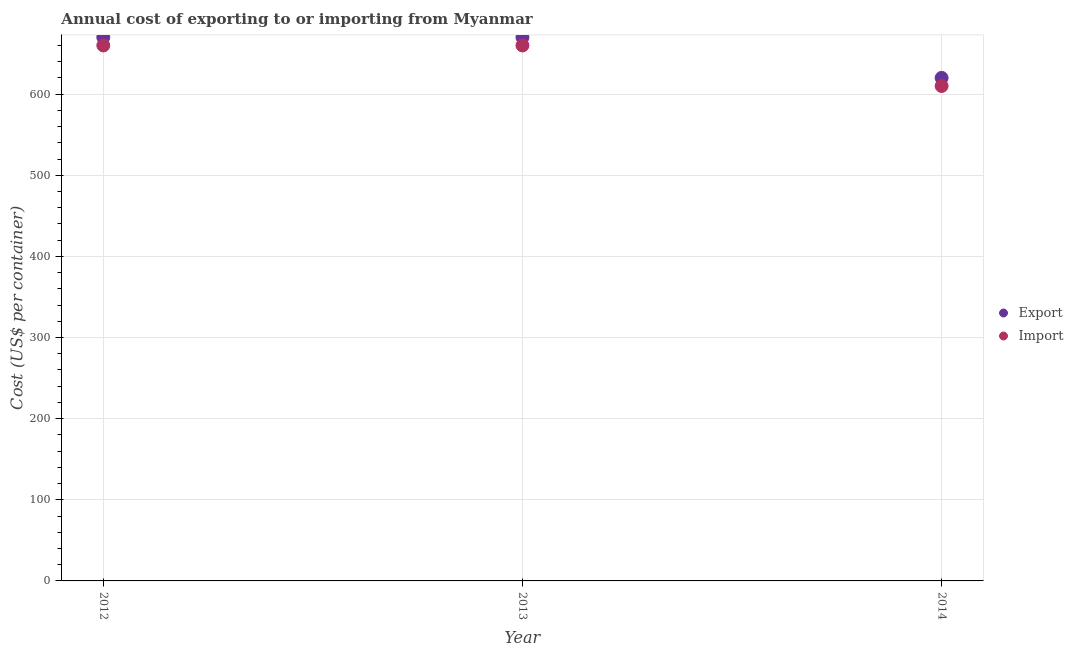Is the number of dotlines equal to the number of legend labels?
Your answer should be compact. Yes. What is the import cost in 2013?
Your response must be concise. 660. Across all years, what is the maximum import cost?
Offer a very short reply. 660. Across all years, what is the minimum export cost?
Ensure brevity in your answer.  620. In which year was the export cost maximum?
Your answer should be very brief. 2012. In which year was the export cost minimum?
Keep it short and to the point. 2014. What is the total import cost in the graph?
Provide a succinct answer. 1930. What is the difference between the import cost in 2014 and the export cost in 2012?
Offer a terse response. -60. What is the average import cost per year?
Your response must be concise. 643.33. In the year 2013, what is the difference between the import cost and export cost?
Ensure brevity in your answer.  -10. What is the ratio of the export cost in 2013 to that in 2014?
Your answer should be very brief. 1.08. Is the import cost in 2012 less than that in 2014?
Offer a terse response. No. Is the difference between the export cost in 2012 and 2013 greater than the difference between the import cost in 2012 and 2013?
Make the answer very short. No. What is the difference between the highest and the second highest export cost?
Ensure brevity in your answer.  0. What is the difference between the highest and the lowest import cost?
Offer a very short reply. 50. In how many years, is the import cost greater than the average import cost taken over all years?
Your answer should be compact. 2. Is the import cost strictly less than the export cost over the years?
Give a very brief answer. Yes. How many dotlines are there?
Make the answer very short. 2. How many years are there in the graph?
Make the answer very short. 3. Does the graph contain any zero values?
Provide a short and direct response. No. Does the graph contain grids?
Your answer should be compact. Yes. How many legend labels are there?
Provide a short and direct response. 2. What is the title of the graph?
Make the answer very short. Annual cost of exporting to or importing from Myanmar. Does "Lower secondary rate" appear as one of the legend labels in the graph?
Provide a short and direct response. No. What is the label or title of the Y-axis?
Keep it short and to the point. Cost (US$ per container). What is the Cost (US$ per container) in Export in 2012?
Ensure brevity in your answer.  670. What is the Cost (US$ per container) of Import in 2012?
Provide a succinct answer. 660. What is the Cost (US$ per container) in Export in 2013?
Ensure brevity in your answer.  670. What is the Cost (US$ per container) in Import in 2013?
Offer a very short reply. 660. What is the Cost (US$ per container) of Export in 2014?
Offer a very short reply. 620. What is the Cost (US$ per container) in Import in 2014?
Provide a succinct answer. 610. Across all years, what is the maximum Cost (US$ per container) of Export?
Offer a very short reply. 670. Across all years, what is the maximum Cost (US$ per container) in Import?
Make the answer very short. 660. Across all years, what is the minimum Cost (US$ per container) in Export?
Offer a terse response. 620. Across all years, what is the minimum Cost (US$ per container) of Import?
Your response must be concise. 610. What is the total Cost (US$ per container) of Export in the graph?
Ensure brevity in your answer.  1960. What is the total Cost (US$ per container) of Import in the graph?
Keep it short and to the point. 1930. What is the difference between the Cost (US$ per container) in Import in 2012 and that in 2013?
Your response must be concise. 0. What is the difference between the Cost (US$ per container) of Export in 2012 and that in 2014?
Offer a very short reply. 50. What is the difference between the Cost (US$ per container) of Import in 2013 and that in 2014?
Offer a very short reply. 50. What is the average Cost (US$ per container) of Export per year?
Give a very brief answer. 653.33. What is the average Cost (US$ per container) in Import per year?
Ensure brevity in your answer.  643.33. In the year 2012, what is the difference between the Cost (US$ per container) of Export and Cost (US$ per container) of Import?
Keep it short and to the point. 10. What is the ratio of the Cost (US$ per container) of Export in 2012 to that in 2013?
Offer a very short reply. 1. What is the ratio of the Cost (US$ per container) of Import in 2012 to that in 2013?
Give a very brief answer. 1. What is the ratio of the Cost (US$ per container) of Export in 2012 to that in 2014?
Your answer should be very brief. 1.08. What is the ratio of the Cost (US$ per container) of Import in 2012 to that in 2014?
Keep it short and to the point. 1.08. What is the ratio of the Cost (US$ per container) in Export in 2013 to that in 2014?
Ensure brevity in your answer.  1.08. What is the ratio of the Cost (US$ per container) of Import in 2013 to that in 2014?
Offer a very short reply. 1.08. What is the difference between the highest and the second highest Cost (US$ per container) in Import?
Your response must be concise. 0. 